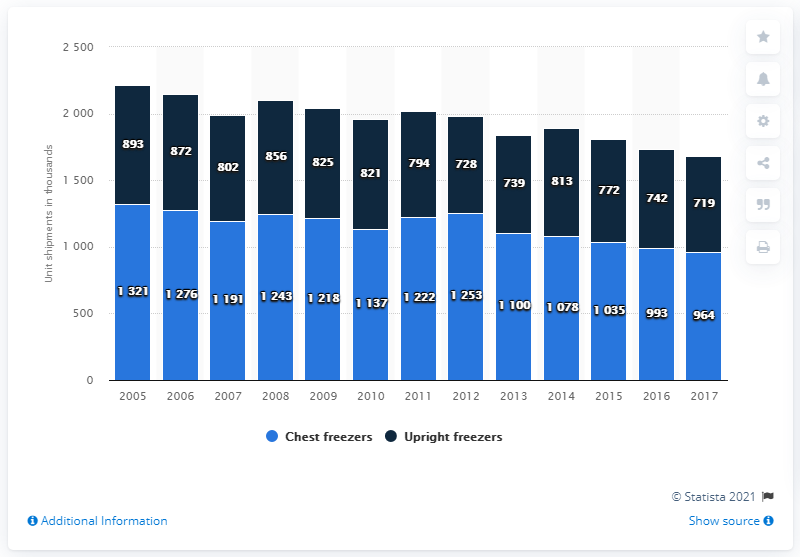Outline some significant characteristics in this image. In 2017, Appliance Magazine forecasted unit shipments for chest freezers. 